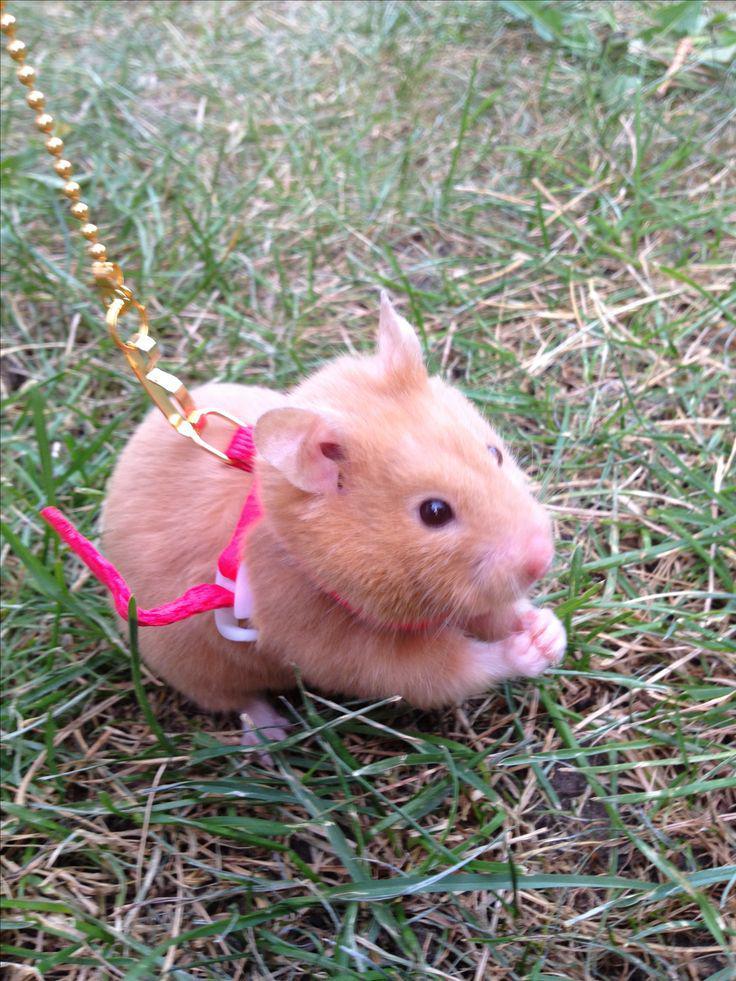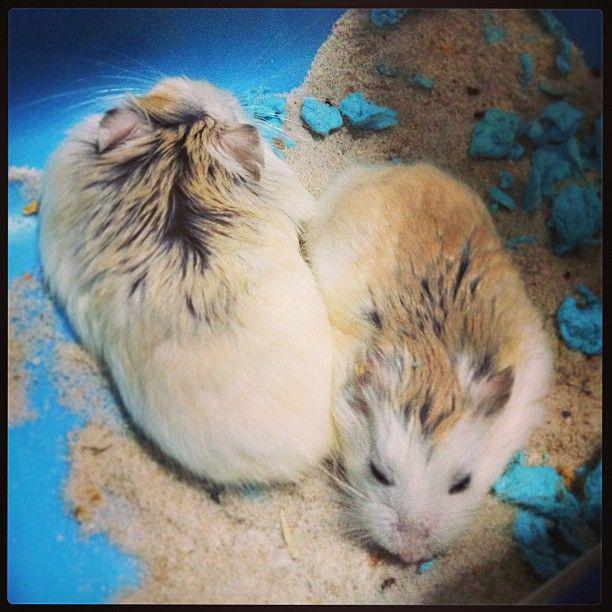The first image is the image on the left, the second image is the image on the right. Examine the images to the left and right. Is the description "There are no more than three rodents" accurate? Answer yes or no. Yes. The first image is the image on the left, the second image is the image on the right. Evaluate the accuracy of this statement regarding the images: "One image shows a cluster of pets inside something with ears.". Is it true? Answer yes or no. No. 